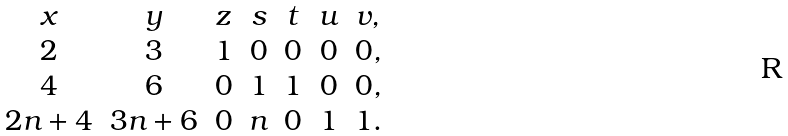<formula> <loc_0><loc_0><loc_500><loc_500>\begin{array} { c c c c c c c } x & y & z & s & t & u & v , \\ 2 & 3 & 1 & 0 & 0 & 0 & 0 , \\ 4 & 6 & 0 & 1 & 1 & 0 & 0 , \\ 2 n + 4 & 3 n + 6 & 0 & n & 0 & 1 & 1 . \end{array}</formula> 